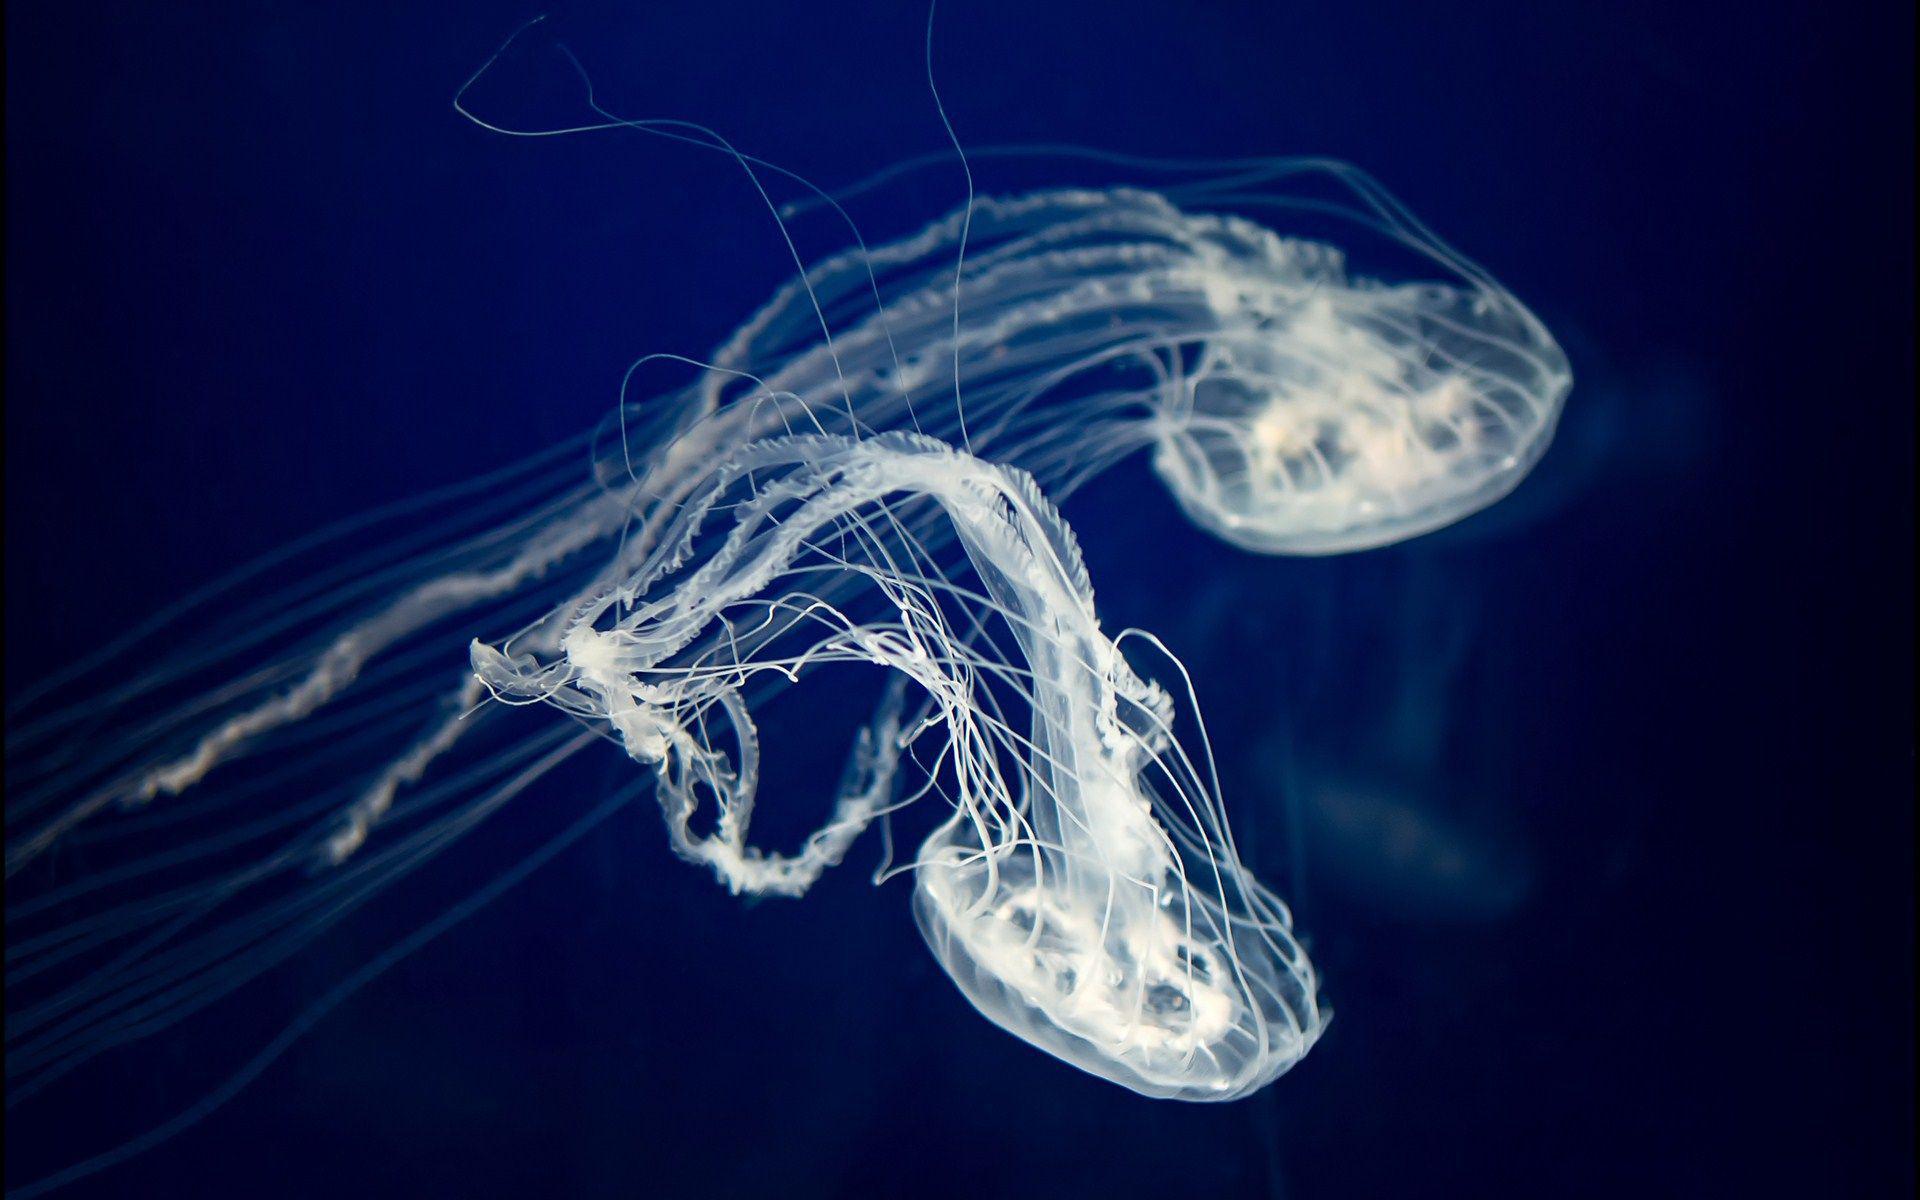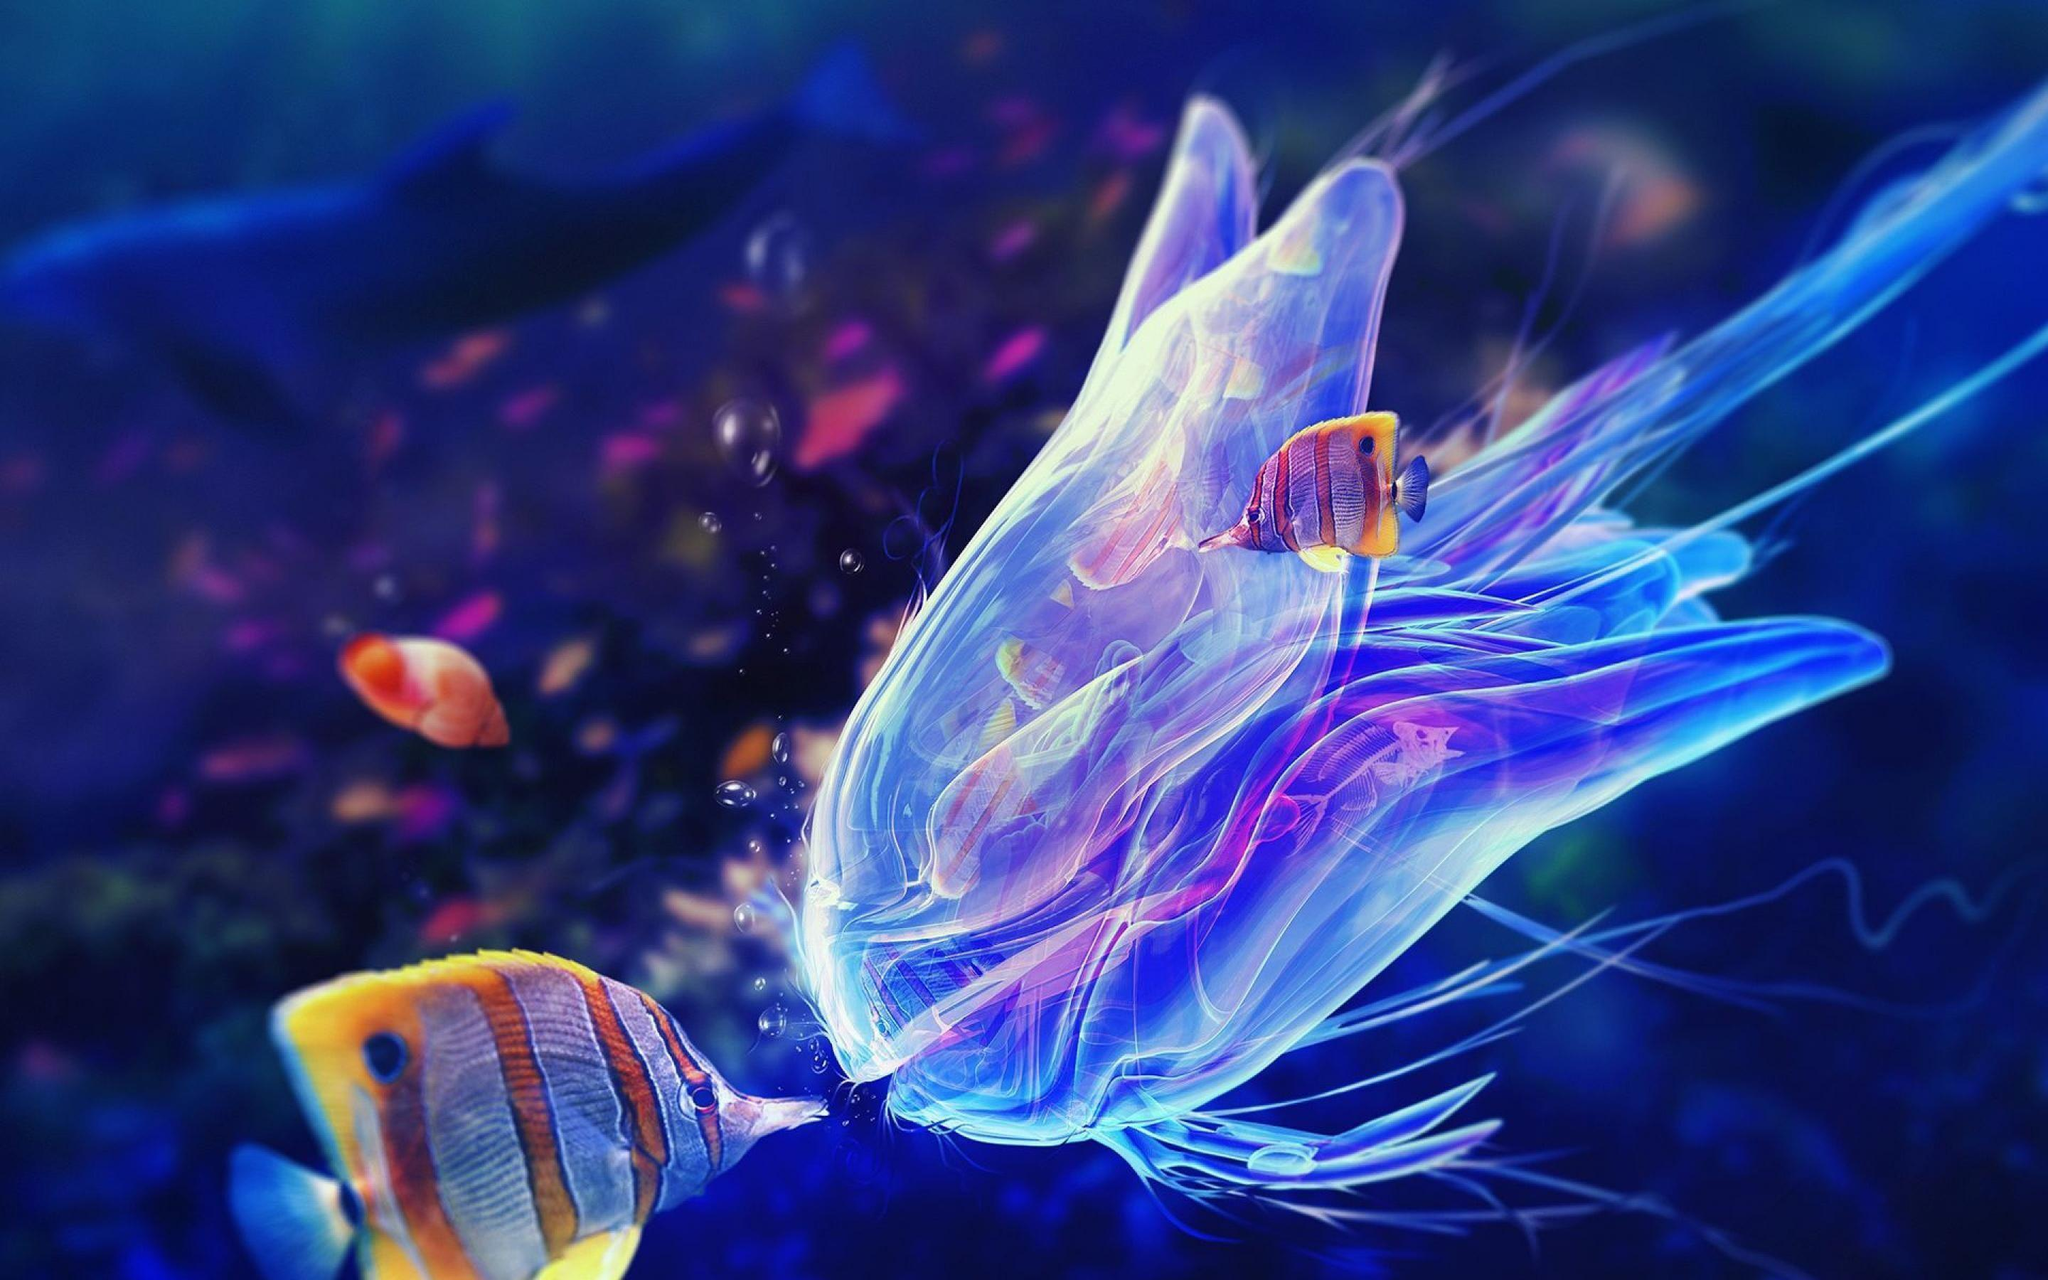The first image is the image on the left, the second image is the image on the right. Analyze the images presented: Is the assertion "There are no more than five jellyfish in the image on the left" valid? Answer yes or no. Yes. 